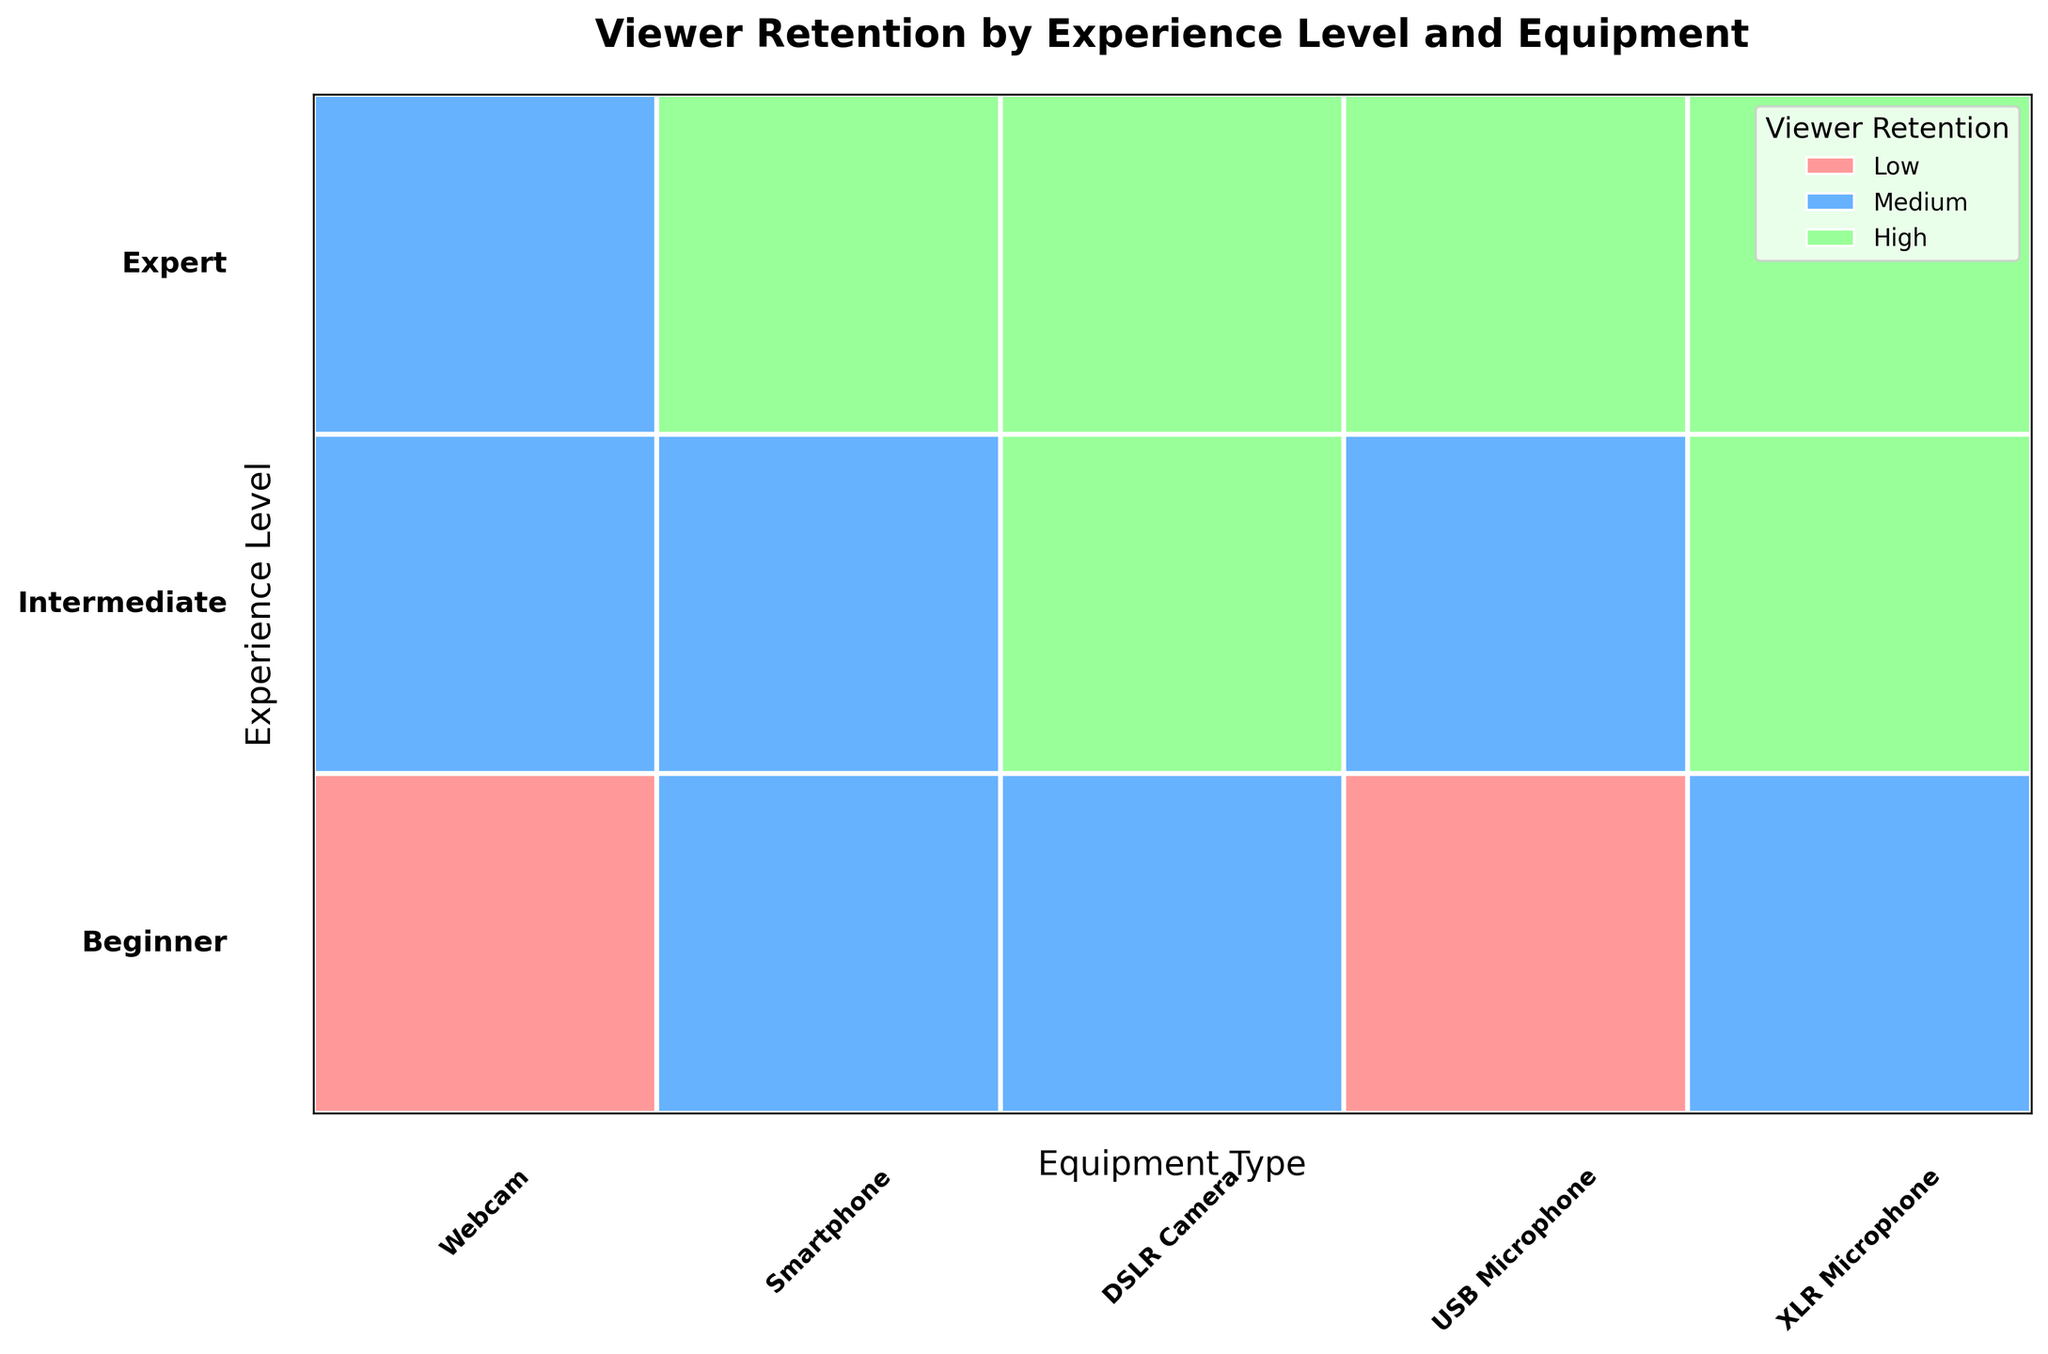What does the title of the plot suggest? The title "Viewer Retention by Experience Level and Equipment" suggests the plot examines how viewer retention varies based on the experience level of the streamer and the type of equipment they use.
Answer: It examines viewer retention based on experience level and equipment type How many viewer retention categories are there in the plot? The legend in the upper right corner indicates the presence of three viewer retention categories: Low, Medium, and High.
Answer: Three categories What color represents the 'High' viewer retention level? The legend shows the color associated with 'High' viewer retention. By observing the legend colors, we can see that 'High' retention is represented by a green color.
Answer: Green Which equipment type is associated with 'High' viewer retention for Intermediate streamers? Look at the rectangles in the Intermediate row and identify those with green segments (High retention). Intermediate streamers achieve high viewer retention when using DSLRs and XLR Microphones.
Answer: DSLR Camera and XLR Microphone Among Beginners, which equipment leads to 'Low' viewer retention? In the Beginner row, find the equipment types with red segments (Low retention). The Webcam and USB Microphone have 'Low' viewer retention segments.
Answer: Webcam and USB Microphone Does any equipment have 'High' viewer retention across all experience levels? Find the equipment types that consistently have a green segment in all three experience level rows. The DSLR Camera and XLR Microphone both show 'High' viewer retention across all experience levels.
Answer: DSLR Camera and XLR Microphone Which experience level has the highest variety in viewer retention for Webcam users? Look at the Webcam column and observe the distribution of viewer retention colors (red, blue, green) across different experience levels. Beginners have both 'Low' and 'Medium', and Experts have 'Medium' and 'High'. The Intermediate level only shows 'Medium'.
Answer: Experts How does viewer retention for Smartphone users differ between Experts and Beginners? Compare the colors for Smartphone users in the Beginner and Expert rows. Beginners have 'Medium' retention, while Experts have 'High' retention.
Answer: Beginners: Medium; Experts: High For which experience level is equipment most diverse in its impact on viewer retention? Compare the spread of colors (indicating different retention levels) across each experience level row. The Beginner level shows the most diversity, with equipment resulting in 'Low', 'Medium', and 'High' retention.
Answer: Beginner How many different equipment types are featured in the plot? Count the number of distinct equipment labels along the horizontal axis. There are five equipment types: Webcam, Smartphone, DSLR Camera, USB Microphone, and XLR Microphone.
Answer: Five For Experts, which two equipment types have the highest viewer retention? In the Expert row, identify equipment types with green (High retention) segments. Both Smartphone, DSLR Camera, and XLR Microphone have 'High' retention.
Answer: Smartphone, DSLR Camera, and XLR Microphone 